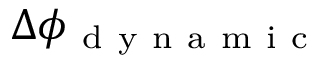<formula> <loc_0><loc_0><loc_500><loc_500>\Delta \phi _ { d y n a m i c }</formula> 